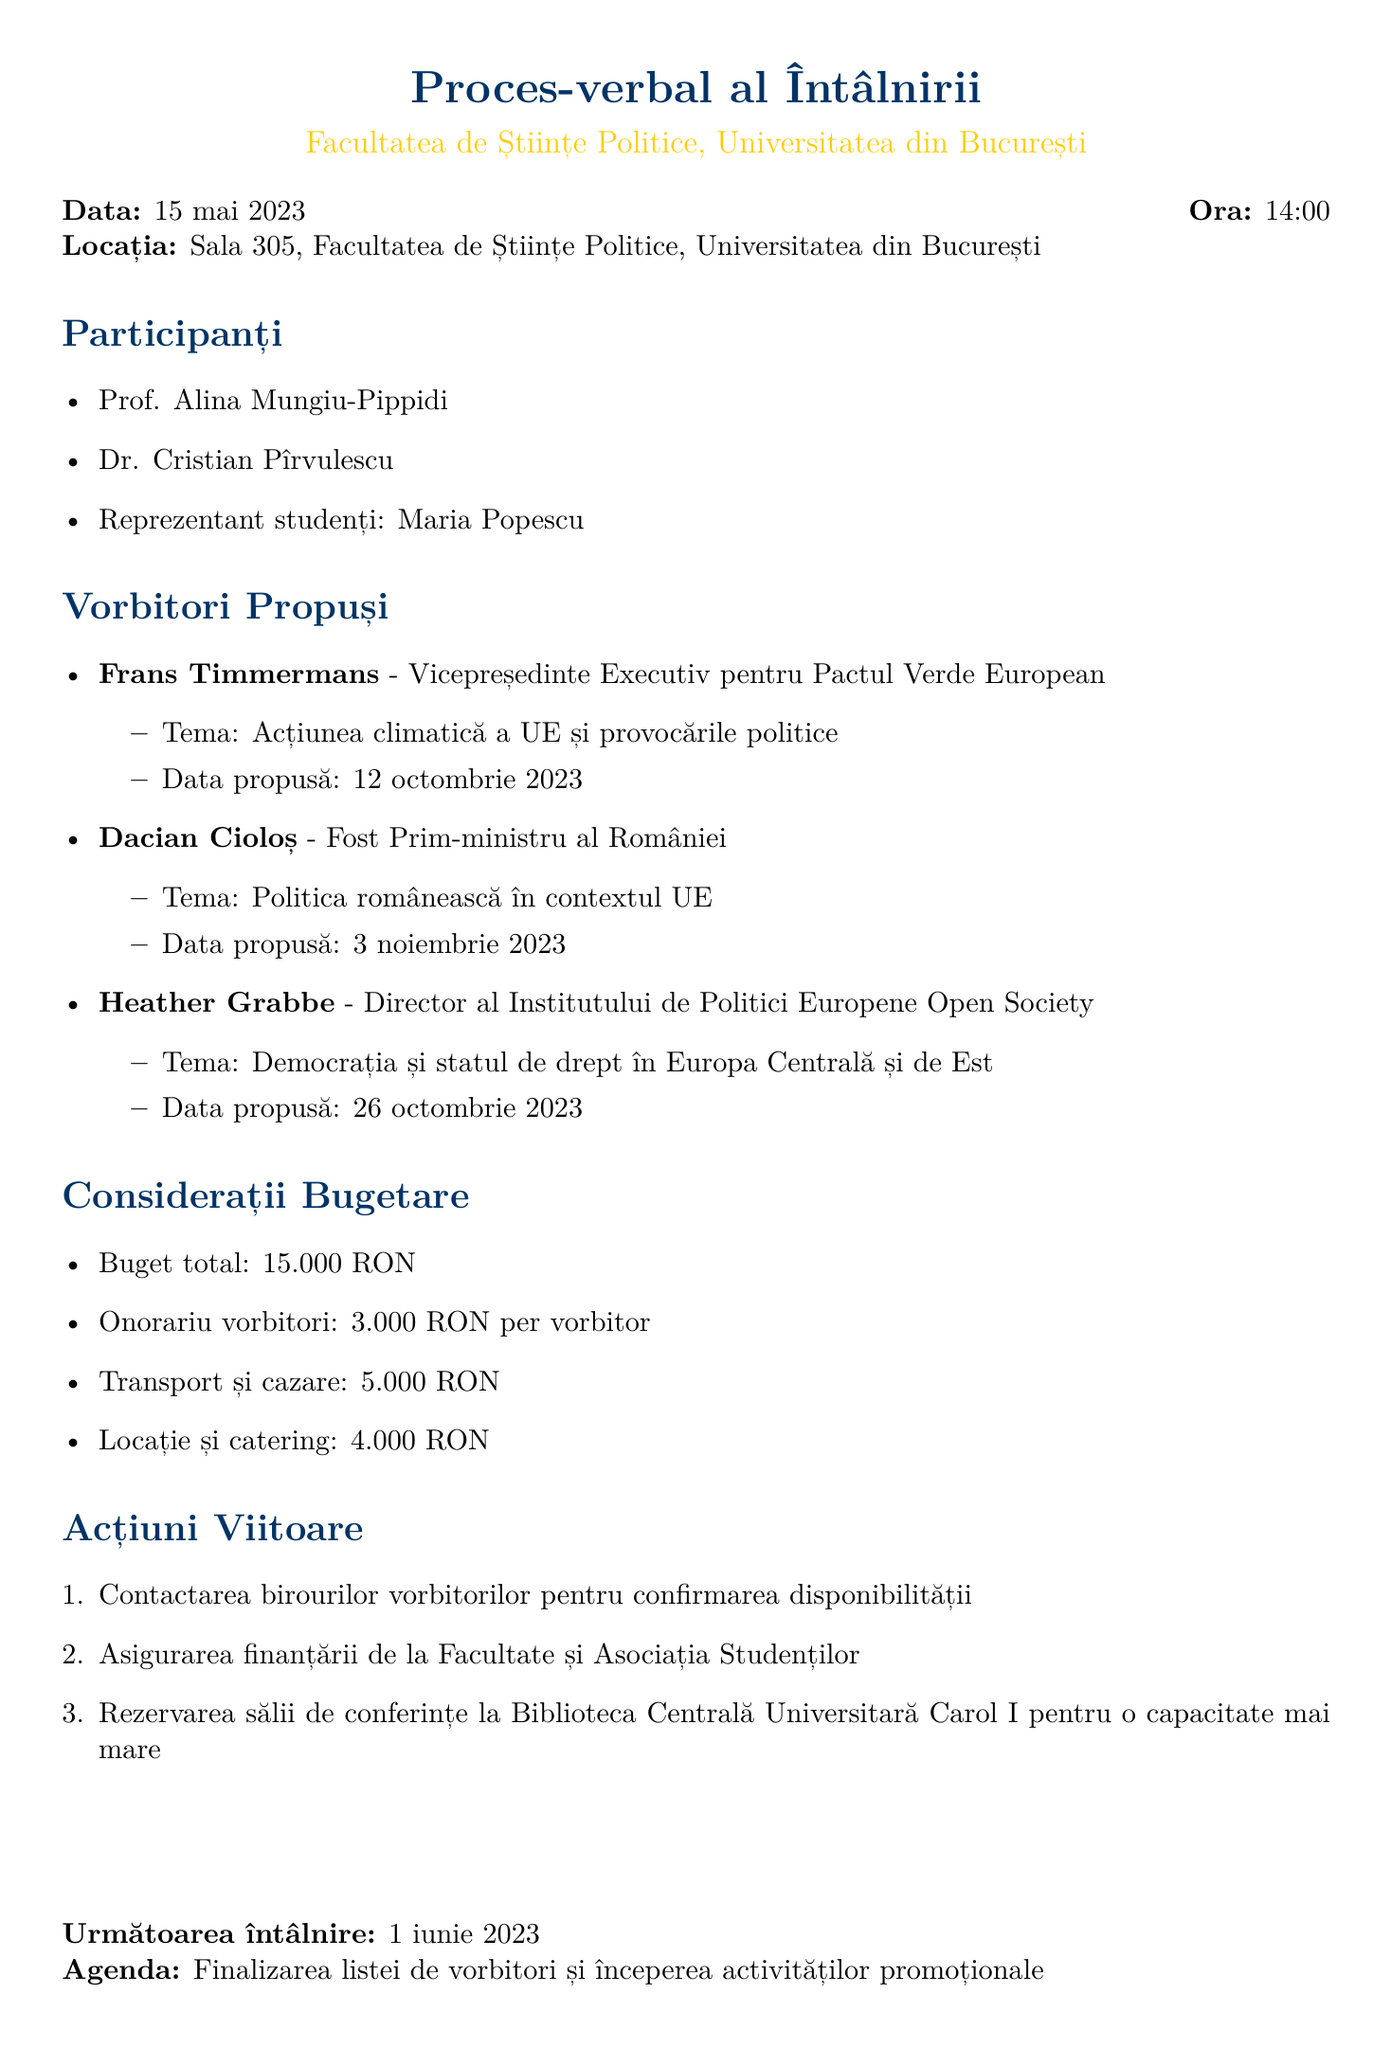what is the date of the meeting? The date of the meeting is specified in the document as the day it took place, which is May 15, 2023.
Answer: May 15, 2023 who proposed to speak about EU Climate Action? The document lists Frans Timmermans as a proposed speaker focusing on EU Climate Action.
Answer: Frans Timmermans how much is the total budget for the symposium? The total budget is explicitly mentioned in the document and outlines the overall financial allocation for the event.
Answer: 15,000 RON when is the next meeting scheduled? The details for the next scheduled meeting, including the date, are found in the document.
Answer: June 1, 2023 what is the honorarium for each speaker? The document states the amount allocated to each speaker as part of the budget considerations.
Answer: 3,000 RON per speaker which venue is considered for a larger capacity? The document specifies a venue intended for a higher capacity requirement for the symposium.
Answer: Carol I Central University Library how many proposed speakers are listed in the document? The number of speakers proposed is clearly enumerated in the section about speakers.
Answer: Three what topic will Dacian Cioloș speak about? The document details the topic associated with Dacian Cioloș and how it relates to his position.
Answer: Romanian Politics in the EU Context 